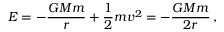Convert formula to latex. <formula><loc_0><loc_0><loc_500><loc_500>E = - \frac { G M m } { r } + \frac { 1 } { 2 } m v ^ { 2 } = - \frac { G M m } { 2 r } \, ,</formula> 